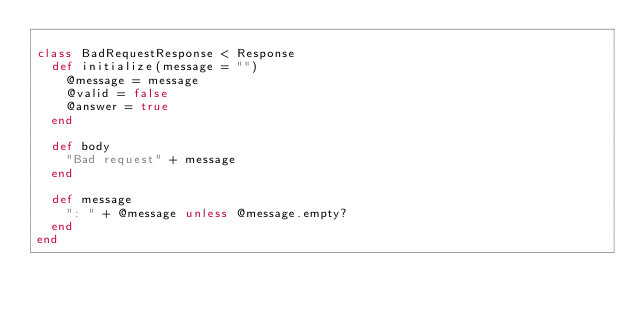<code> <loc_0><loc_0><loc_500><loc_500><_Ruby_>
class BadRequestResponse < Response
  def initialize(message = "")
    @message = message
    @valid = false
    @answer = true
  end

  def body
    "Bad request" + message
  end

  def message
    ": " + @message unless @message.empty?
  end
end
</code> 